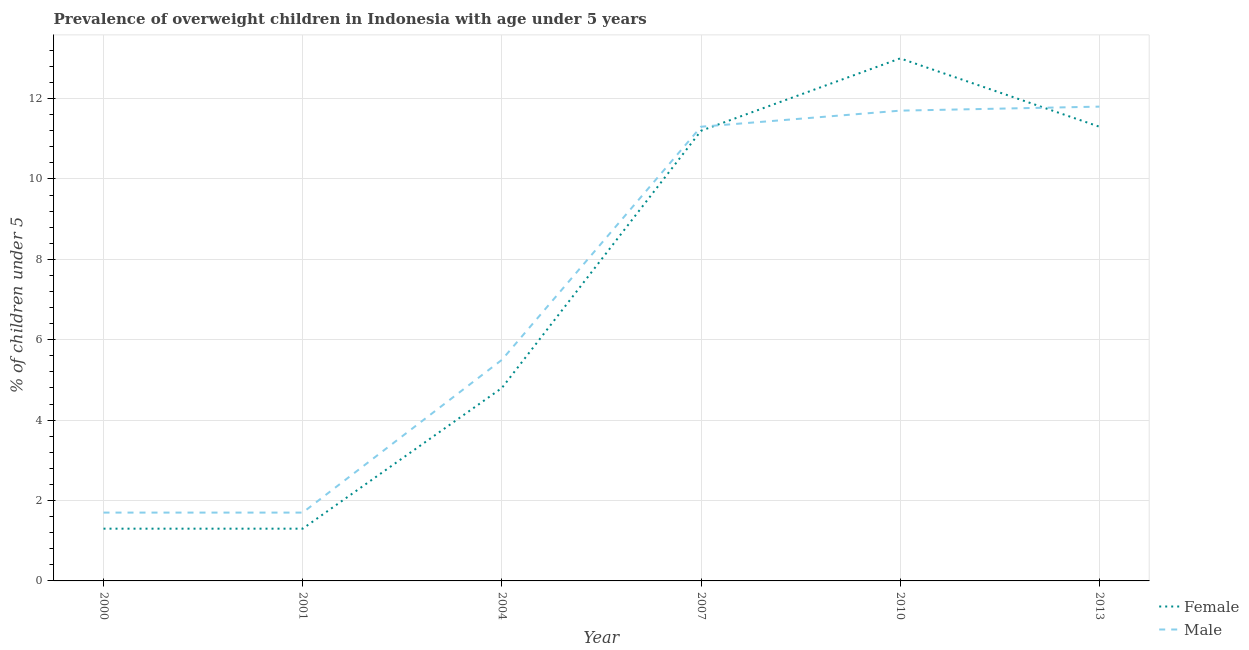Is the number of lines equal to the number of legend labels?
Offer a terse response. Yes. What is the percentage of obese male children in 2004?
Your answer should be very brief. 5.5. Across all years, what is the minimum percentage of obese female children?
Your answer should be very brief. 1.3. What is the total percentage of obese female children in the graph?
Your response must be concise. 42.9. What is the difference between the percentage of obese female children in 2000 and that in 2004?
Ensure brevity in your answer.  -3.5. What is the difference between the percentage of obese female children in 2001 and the percentage of obese male children in 2007?
Ensure brevity in your answer.  -10. What is the average percentage of obese male children per year?
Provide a succinct answer. 7.28. What is the ratio of the percentage of obese male children in 2000 to that in 2004?
Ensure brevity in your answer.  0.31. Is the percentage of obese male children in 2001 less than that in 2010?
Provide a short and direct response. Yes. Is the difference between the percentage of obese female children in 2001 and 2013 greater than the difference between the percentage of obese male children in 2001 and 2013?
Your answer should be very brief. Yes. What is the difference between the highest and the second highest percentage of obese female children?
Your answer should be very brief. 1.7. What is the difference between the highest and the lowest percentage of obese male children?
Provide a succinct answer. 10.1. In how many years, is the percentage of obese male children greater than the average percentage of obese male children taken over all years?
Offer a very short reply. 3. Is the sum of the percentage of obese male children in 2001 and 2007 greater than the maximum percentage of obese female children across all years?
Provide a short and direct response. Yes. Is the percentage of obese male children strictly greater than the percentage of obese female children over the years?
Make the answer very short. No. How many lines are there?
Make the answer very short. 2. How many years are there in the graph?
Offer a terse response. 6. Does the graph contain grids?
Ensure brevity in your answer.  Yes. Where does the legend appear in the graph?
Give a very brief answer. Bottom right. How many legend labels are there?
Your answer should be compact. 2. How are the legend labels stacked?
Your answer should be very brief. Vertical. What is the title of the graph?
Give a very brief answer. Prevalence of overweight children in Indonesia with age under 5 years. Does "Long-term debt" appear as one of the legend labels in the graph?
Offer a very short reply. No. What is the label or title of the X-axis?
Your answer should be very brief. Year. What is the label or title of the Y-axis?
Make the answer very short.  % of children under 5. What is the  % of children under 5 of Female in 2000?
Offer a terse response. 1.3. What is the  % of children under 5 of Male in 2000?
Your response must be concise. 1.7. What is the  % of children under 5 in Female in 2001?
Offer a very short reply. 1.3. What is the  % of children under 5 in Male in 2001?
Your answer should be compact. 1.7. What is the  % of children under 5 of Female in 2004?
Provide a short and direct response. 4.8. What is the  % of children under 5 in Male in 2004?
Offer a very short reply. 5.5. What is the  % of children under 5 in Female in 2007?
Provide a succinct answer. 11.2. What is the  % of children under 5 in Male in 2007?
Make the answer very short. 11.3. What is the  % of children under 5 in Female in 2010?
Your answer should be very brief. 13. What is the  % of children under 5 in Male in 2010?
Offer a terse response. 11.7. What is the  % of children under 5 in Female in 2013?
Offer a very short reply. 11.3. What is the  % of children under 5 in Male in 2013?
Provide a short and direct response. 11.8. Across all years, what is the maximum  % of children under 5 of Female?
Your answer should be compact. 13. Across all years, what is the maximum  % of children under 5 in Male?
Your answer should be compact. 11.8. Across all years, what is the minimum  % of children under 5 of Female?
Your answer should be very brief. 1.3. Across all years, what is the minimum  % of children under 5 in Male?
Ensure brevity in your answer.  1.7. What is the total  % of children under 5 in Female in the graph?
Make the answer very short. 42.9. What is the total  % of children under 5 of Male in the graph?
Make the answer very short. 43.7. What is the difference between the  % of children under 5 of Female in 2000 and that in 2001?
Your response must be concise. 0. What is the difference between the  % of children under 5 of Male in 2000 and that in 2001?
Provide a short and direct response. 0. What is the difference between the  % of children under 5 in Female in 2000 and that in 2004?
Your answer should be compact. -3.5. What is the difference between the  % of children under 5 of Female in 2000 and that in 2007?
Ensure brevity in your answer.  -9.9. What is the difference between the  % of children under 5 of Male in 2000 and that in 2013?
Provide a short and direct response. -10.1. What is the difference between the  % of children under 5 of Male in 2001 and that in 2007?
Your response must be concise. -9.6. What is the difference between the  % of children under 5 in Female in 2001 and that in 2013?
Ensure brevity in your answer.  -10. What is the difference between the  % of children under 5 of Male in 2001 and that in 2013?
Your answer should be compact. -10.1. What is the difference between the  % of children under 5 in Male in 2004 and that in 2007?
Offer a very short reply. -5.8. What is the difference between the  % of children under 5 in Male in 2004 and that in 2010?
Provide a succinct answer. -6.2. What is the difference between the  % of children under 5 in Female in 2004 and that in 2013?
Make the answer very short. -6.5. What is the difference between the  % of children under 5 of Female in 2007 and that in 2010?
Your response must be concise. -1.8. What is the difference between the  % of children under 5 in Female in 2007 and that in 2013?
Provide a short and direct response. -0.1. What is the difference between the  % of children under 5 of Male in 2010 and that in 2013?
Your answer should be compact. -0.1. What is the difference between the  % of children under 5 of Female in 2000 and the  % of children under 5 of Male in 2001?
Provide a succinct answer. -0.4. What is the difference between the  % of children under 5 of Female in 2000 and the  % of children under 5 of Male in 2004?
Ensure brevity in your answer.  -4.2. What is the difference between the  % of children under 5 of Female in 2001 and the  % of children under 5 of Male in 2010?
Your answer should be compact. -10.4. What is the difference between the  % of children under 5 of Female in 2001 and the  % of children under 5 of Male in 2013?
Make the answer very short. -10.5. What is the difference between the  % of children under 5 of Female in 2004 and the  % of children under 5 of Male in 2010?
Your answer should be very brief. -6.9. What is the difference between the  % of children under 5 of Female in 2004 and the  % of children under 5 of Male in 2013?
Offer a terse response. -7. What is the difference between the  % of children under 5 of Female in 2007 and the  % of children under 5 of Male in 2010?
Provide a succinct answer. -0.5. What is the difference between the  % of children under 5 of Female in 2007 and the  % of children under 5 of Male in 2013?
Keep it short and to the point. -0.6. What is the average  % of children under 5 of Female per year?
Your answer should be compact. 7.15. What is the average  % of children under 5 in Male per year?
Your answer should be very brief. 7.28. In the year 2000, what is the difference between the  % of children under 5 of Female and  % of children under 5 of Male?
Keep it short and to the point. -0.4. In the year 2001, what is the difference between the  % of children under 5 in Female and  % of children under 5 in Male?
Give a very brief answer. -0.4. In the year 2004, what is the difference between the  % of children under 5 of Female and  % of children under 5 of Male?
Your answer should be compact. -0.7. In the year 2010, what is the difference between the  % of children under 5 of Female and  % of children under 5 of Male?
Make the answer very short. 1.3. In the year 2013, what is the difference between the  % of children under 5 in Female and  % of children under 5 in Male?
Your answer should be compact. -0.5. What is the ratio of the  % of children under 5 in Male in 2000 to that in 2001?
Offer a very short reply. 1. What is the ratio of the  % of children under 5 of Female in 2000 to that in 2004?
Your response must be concise. 0.27. What is the ratio of the  % of children under 5 of Male in 2000 to that in 2004?
Keep it short and to the point. 0.31. What is the ratio of the  % of children under 5 of Female in 2000 to that in 2007?
Provide a short and direct response. 0.12. What is the ratio of the  % of children under 5 of Male in 2000 to that in 2007?
Your answer should be very brief. 0.15. What is the ratio of the  % of children under 5 of Female in 2000 to that in 2010?
Offer a terse response. 0.1. What is the ratio of the  % of children under 5 of Male in 2000 to that in 2010?
Keep it short and to the point. 0.15. What is the ratio of the  % of children under 5 in Female in 2000 to that in 2013?
Provide a succinct answer. 0.12. What is the ratio of the  % of children under 5 of Male in 2000 to that in 2013?
Give a very brief answer. 0.14. What is the ratio of the  % of children under 5 in Female in 2001 to that in 2004?
Make the answer very short. 0.27. What is the ratio of the  % of children under 5 of Male in 2001 to that in 2004?
Keep it short and to the point. 0.31. What is the ratio of the  % of children under 5 in Female in 2001 to that in 2007?
Ensure brevity in your answer.  0.12. What is the ratio of the  % of children under 5 in Male in 2001 to that in 2007?
Offer a terse response. 0.15. What is the ratio of the  % of children under 5 in Female in 2001 to that in 2010?
Offer a terse response. 0.1. What is the ratio of the  % of children under 5 of Male in 2001 to that in 2010?
Ensure brevity in your answer.  0.15. What is the ratio of the  % of children under 5 in Female in 2001 to that in 2013?
Make the answer very short. 0.12. What is the ratio of the  % of children under 5 in Male in 2001 to that in 2013?
Ensure brevity in your answer.  0.14. What is the ratio of the  % of children under 5 of Female in 2004 to that in 2007?
Your answer should be very brief. 0.43. What is the ratio of the  % of children under 5 of Male in 2004 to that in 2007?
Keep it short and to the point. 0.49. What is the ratio of the  % of children under 5 in Female in 2004 to that in 2010?
Give a very brief answer. 0.37. What is the ratio of the  % of children under 5 in Male in 2004 to that in 2010?
Provide a succinct answer. 0.47. What is the ratio of the  % of children under 5 in Female in 2004 to that in 2013?
Your answer should be very brief. 0.42. What is the ratio of the  % of children under 5 of Male in 2004 to that in 2013?
Your answer should be compact. 0.47. What is the ratio of the  % of children under 5 of Female in 2007 to that in 2010?
Offer a very short reply. 0.86. What is the ratio of the  % of children under 5 of Male in 2007 to that in 2010?
Your answer should be very brief. 0.97. What is the ratio of the  % of children under 5 of Female in 2007 to that in 2013?
Ensure brevity in your answer.  0.99. What is the ratio of the  % of children under 5 of Male in 2007 to that in 2013?
Your response must be concise. 0.96. What is the ratio of the  % of children under 5 of Female in 2010 to that in 2013?
Keep it short and to the point. 1.15. What is the difference between the highest and the second highest  % of children under 5 of Male?
Your answer should be compact. 0.1. What is the difference between the highest and the lowest  % of children under 5 in Female?
Give a very brief answer. 11.7. 